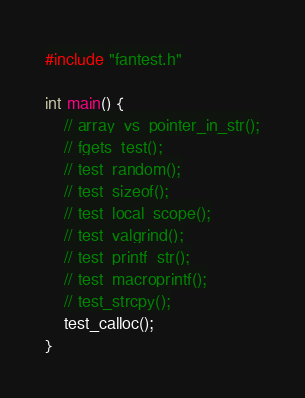<code> <loc_0><loc_0><loc_500><loc_500><_C_>#include "fantest.h"

int main() {
    // array_vs_pointer_in_str();
    // fgets_test();
    // test_random();
    // test_sizeof();
    // test_local_scope();
    // test_valgrind();
    // test_printf_str();
    // test_macroprintf();
    // test_strcpy();
    test_calloc();
}
</code> 